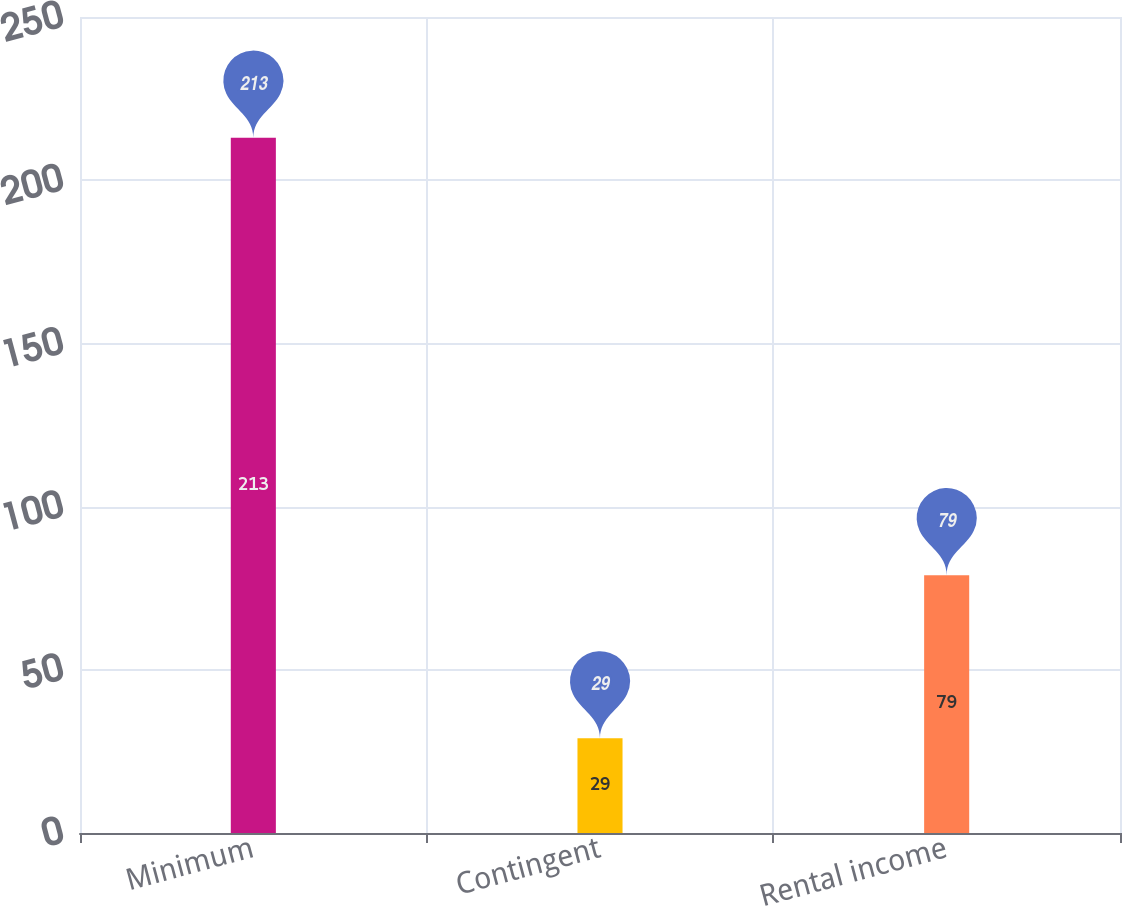Convert chart. <chart><loc_0><loc_0><loc_500><loc_500><bar_chart><fcel>Minimum<fcel>Contingent<fcel>Rental income<nl><fcel>213<fcel>29<fcel>79<nl></chart> 